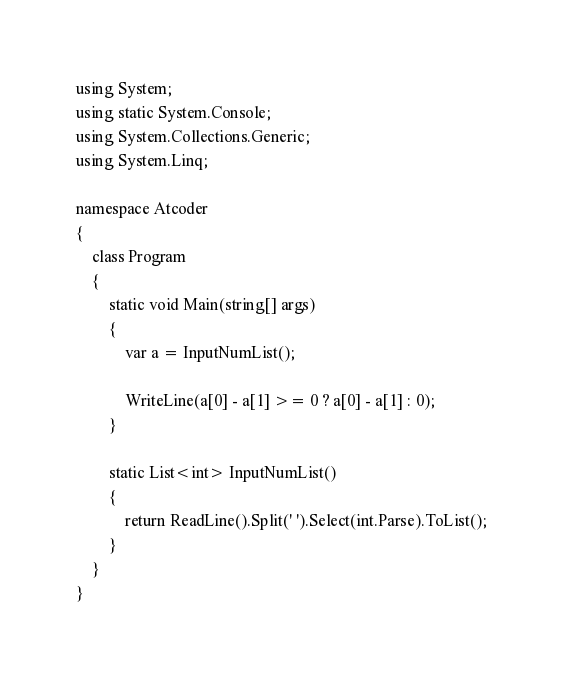Convert code to text. <code><loc_0><loc_0><loc_500><loc_500><_C#_>using System;
using static System.Console;
using System.Collections.Generic;
using System.Linq;

namespace Atcoder
{
    class Program
    {
        static void Main(string[] args)
        {
            var a = InputNumList();

            WriteLine(a[0] - a[1] >= 0 ? a[0] - a[1] : 0);
        }

        static List<int> InputNumList()
        {
            return ReadLine().Split(' ').Select(int.Parse).ToList();
        }
    }
}

</code> 